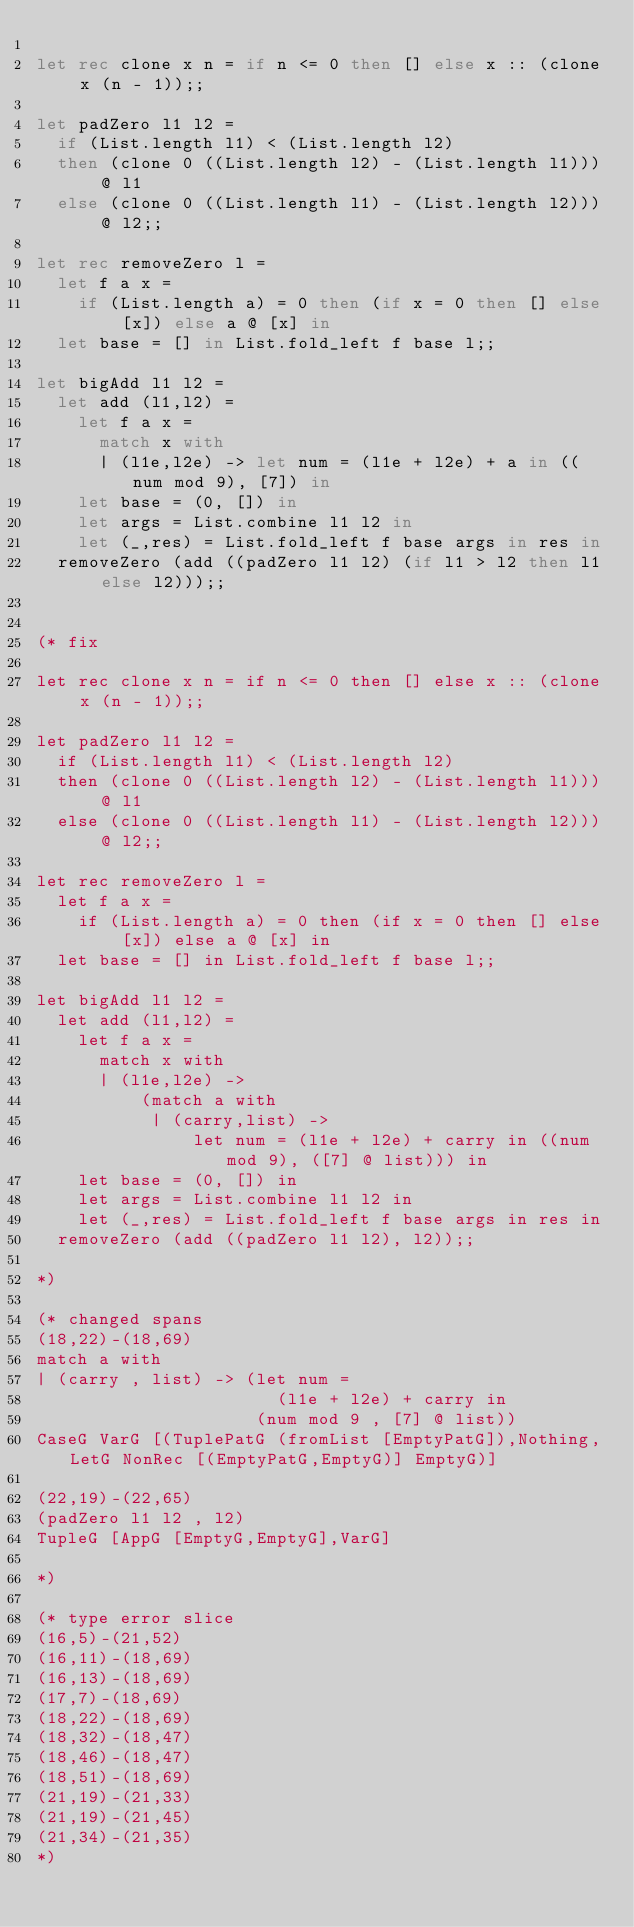Convert code to text. <code><loc_0><loc_0><loc_500><loc_500><_OCaml_>
let rec clone x n = if n <= 0 then [] else x :: (clone x (n - 1));;

let padZero l1 l2 =
  if (List.length l1) < (List.length l2)
  then (clone 0 ((List.length l2) - (List.length l1))) @ l1
  else (clone 0 ((List.length l1) - (List.length l2))) @ l2;;

let rec removeZero l =
  let f a x =
    if (List.length a) = 0 then (if x = 0 then [] else [x]) else a @ [x] in
  let base = [] in List.fold_left f base l;;

let bigAdd l1 l2 =
  let add (l1,l2) =
    let f a x =
      match x with
      | (l1e,l2e) -> let num = (l1e + l2e) + a in ((num mod 9), [7]) in
    let base = (0, []) in
    let args = List.combine l1 l2 in
    let (_,res) = List.fold_left f base args in res in
  removeZero (add ((padZero l1 l2) (if l1 > l2 then l1 else l2)));;


(* fix

let rec clone x n = if n <= 0 then [] else x :: (clone x (n - 1));;

let padZero l1 l2 =
  if (List.length l1) < (List.length l2)
  then (clone 0 ((List.length l2) - (List.length l1))) @ l1
  else (clone 0 ((List.length l1) - (List.length l2))) @ l2;;

let rec removeZero l =
  let f a x =
    if (List.length a) = 0 then (if x = 0 then [] else [x]) else a @ [x] in
  let base = [] in List.fold_left f base l;;

let bigAdd l1 l2 =
  let add (l1,l2) =
    let f a x =
      match x with
      | (l1e,l2e) ->
          (match a with
           | (carry,list) ->
               let num = (l1e + l2e) + carry in ((num mod 9), ([7] @ list))) in
    let base = (0, []) in
    let args = List.combine l1 l2 in
    let (_,res) = List.fold_left f base args in res in
  removeZero (add ((padZero l1 l2), l2));;

*)

(* changed spans
(18,22)-(18,69)
match a with
| (carry , list) -> (let num =
                       (l1e + l2e) + carry in
                     (num mod 9 , [7] @ list))
CaseG VarG [(TuplePatG (fromList [EmptyPatG]),Nothing,LetG NonRec [(EmptyPatG,EmptyG)] EmptyG)]

(22,19)-(22,65)
(padZero l1 l2 , l2)
TupleG [AppG [EmptyG,EmptyG],VarG]

*)

(* type error slice
(16,5)-(21,52)
(16,11)-(18,69)
(16,13)-(18,69)
(17,7)-(18,69)
(18,22)-(18,69)
(18,32)-(18,47)
(18,46)-(18,47)
(18,51)-(18,69)
(21,19)-(21,33)
(21,19)-(21,45)
(21,34)-(21,35)
*)
</code> 